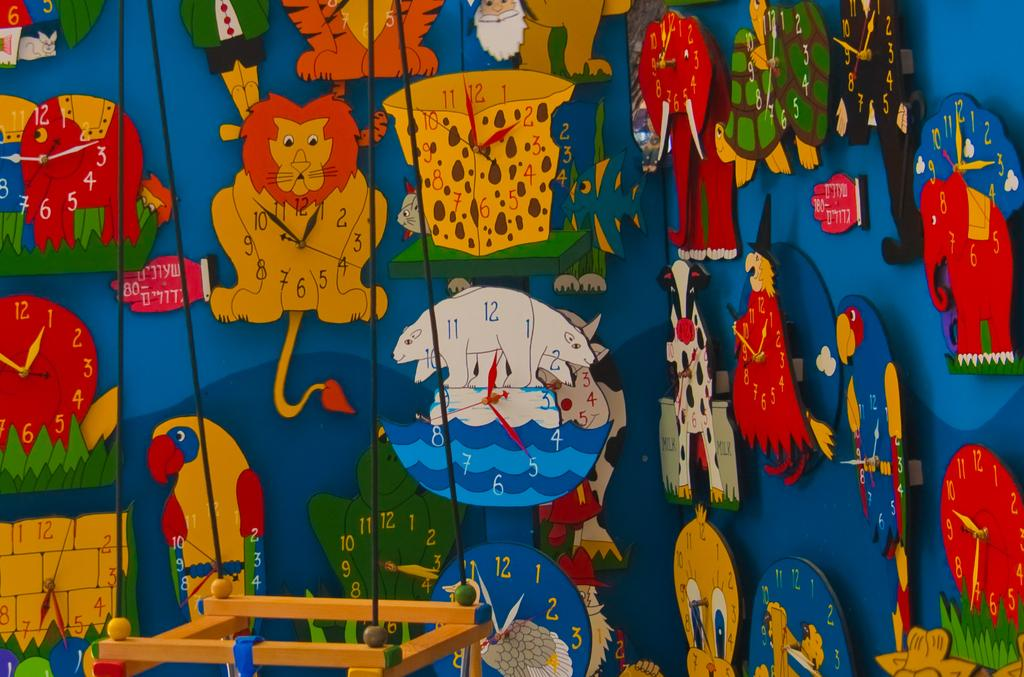What is present on the wall in the image? The wall has clocks in the shape of cartoon animals. Can you describe the appearance of the clocks? The clocks are in the shape of cartoon animals. What else can be seen hanging on the wall? There is there a hanging object with wires? What type of thread is being used to attack the wall in the image? There is no thread or attack present in the image; it features a wall with clocks and a hanging object with wires. 